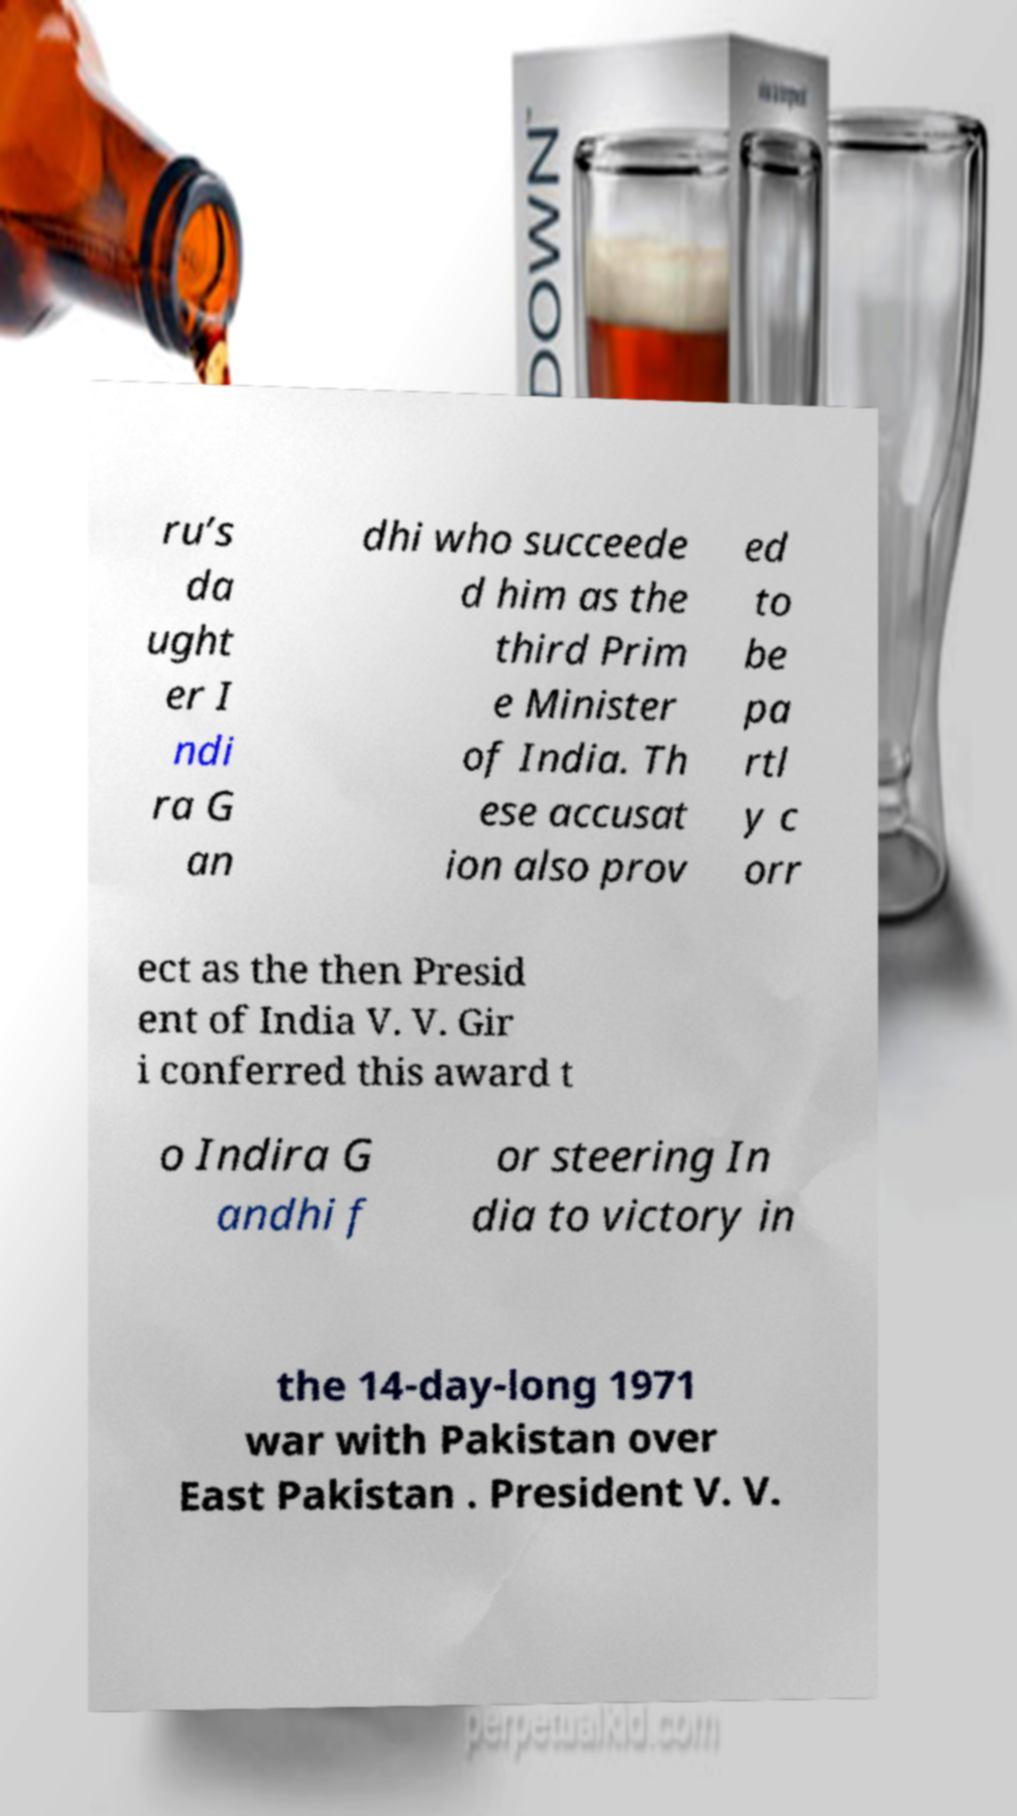Could you assist in decoding the text presented in this image and type it out clearly? ru’s da ught er I ndi ra G an dhi who succeede d him as the third Prim e Minister of India. Th ese accusat ion also prov ed to be pa rtl y c orr ect as the then Presid ent of India V. V. Gir i conferred this award t o Indira G andhi f or steering In dia to victory in the 14-day-long 1971 war with Pakistan over East Pakistan . President V. V. 